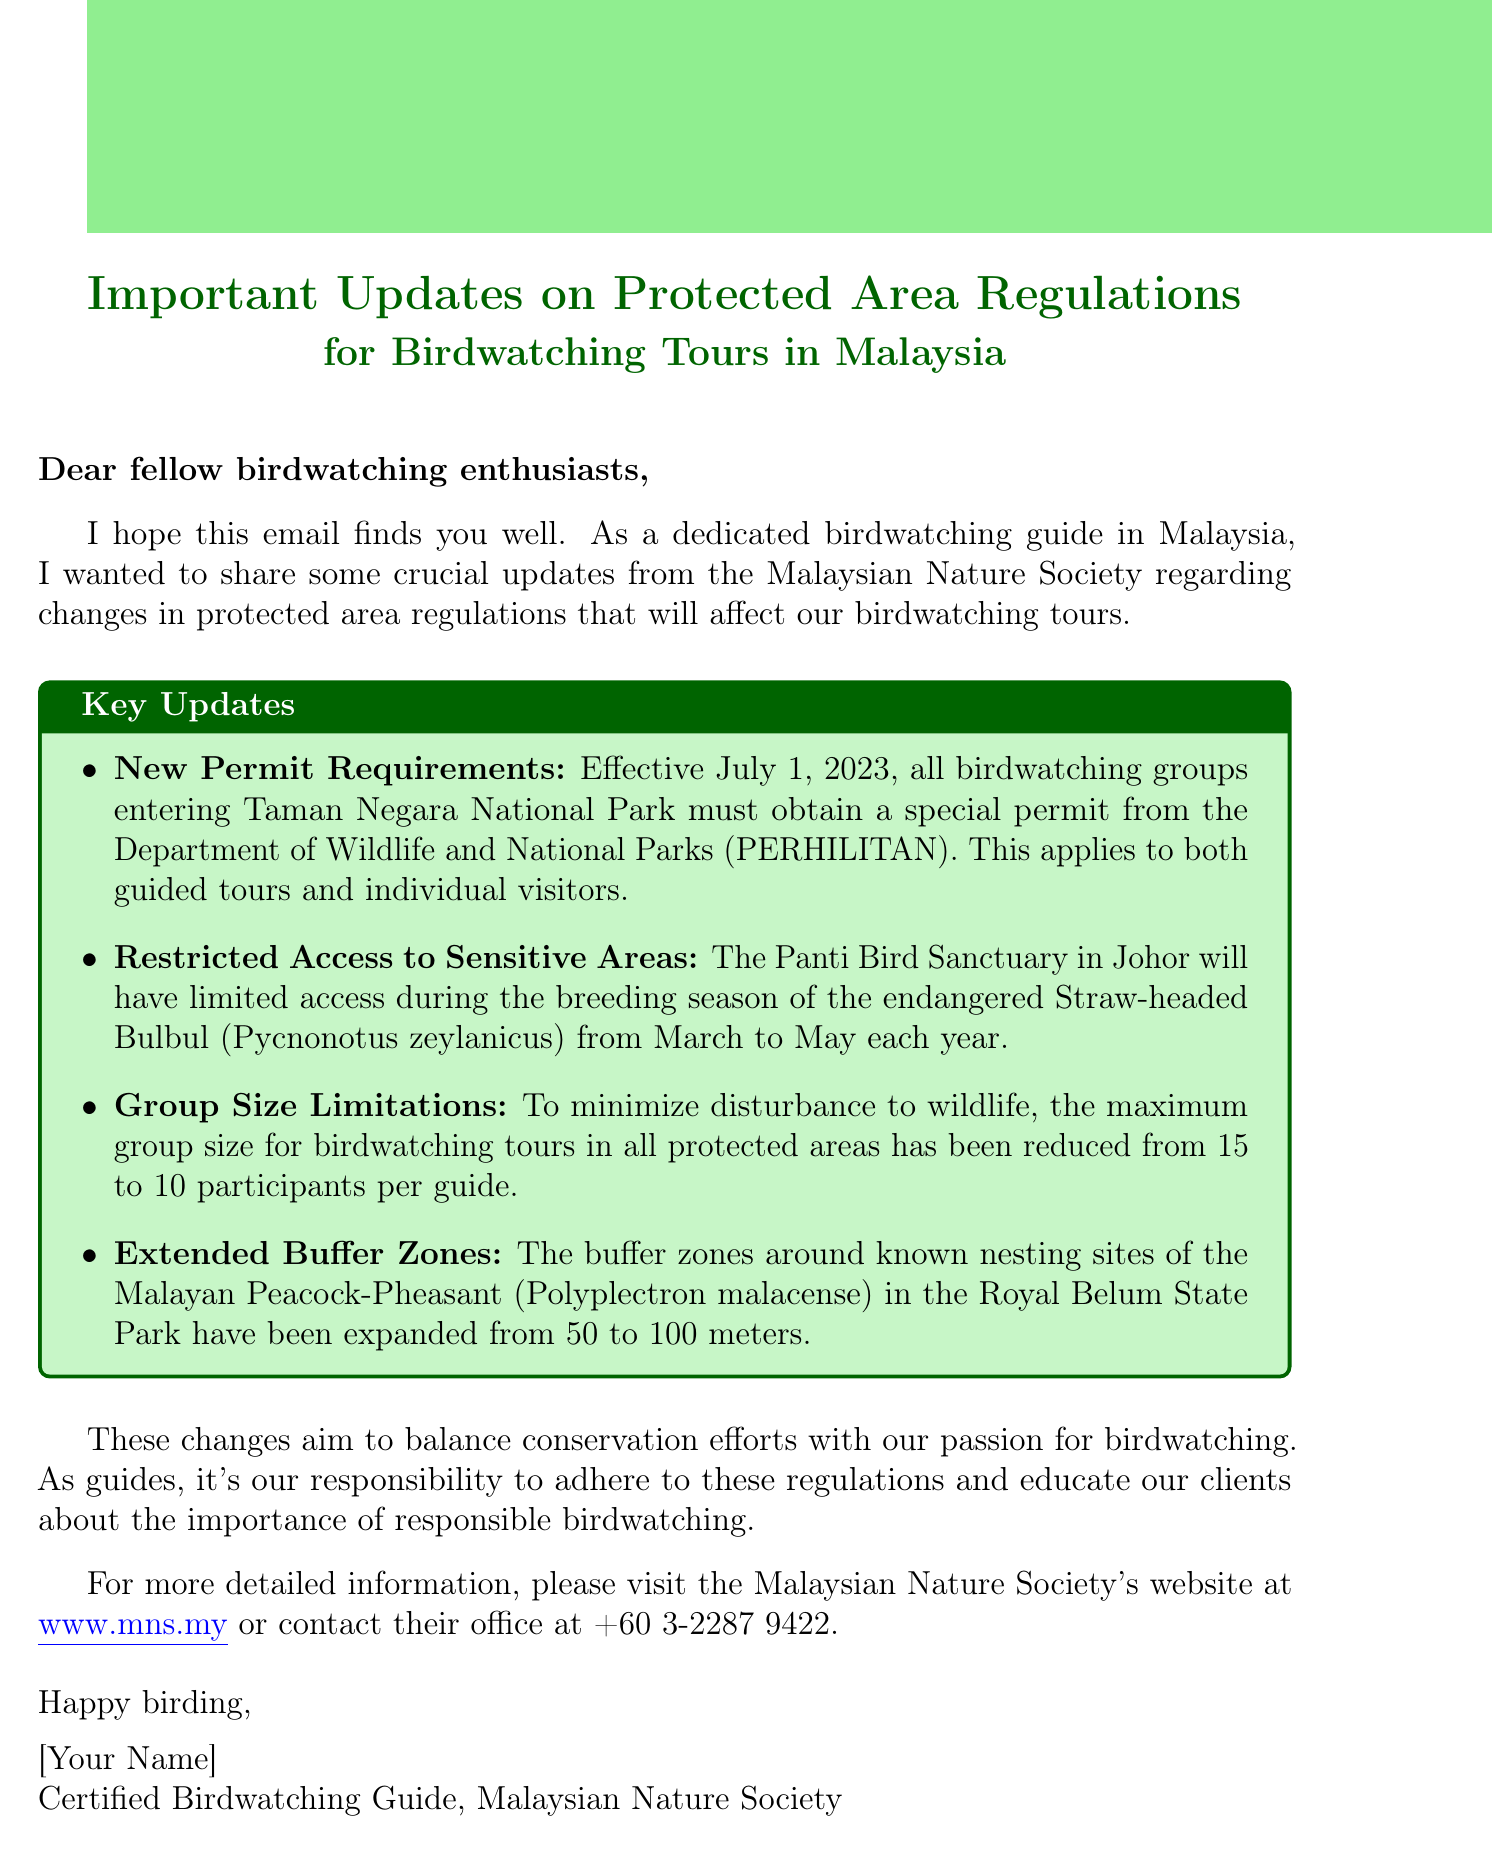What is the subject of the email? The subject of the email provides information about important updates related to protected area regulations for birdwatching tours in Malaysia.
Answer: Important Updates on Protected Area Regulations for Birdwatching Tours in Malaysia When did the new permit requirements take effect? The email states that the new permit requirements for birdwatching groups entering Taman Negara National Park are effective from a specific date.
Answer: July 1, 2023 What is the maximum group size for birdwatching tours now? The email mentions that the maximum group size for birdwatching tours in all protected areas has changed to minimize wildlife disturbance.
Answer: 10 participants Which bird species has restricted access during its breeding season? The email highlights the specific bird species that will have limited access in the Panti Bird Sanctuary during a designated time period.
Answer: Straw-headed Bulbul What is the newly expanded buffer zone around the Malayan Peacock-Pheasant's nesting sites? The email details the increase in buffer zones to protect the nesting sites of a specific bird species in the Royal Belum State Park.
Answer: 100 meters What is the purpose of these changes? The email summarizes the intention behind the updated regulations affecting birdwatching tours.
Answer: Balance conservation efforts How can one contact the Malaysian Nature Society for more information? The email provides a specific contact method for those wanting more details about the changes.
Answer: +60 3-2287 9422 What organization issued these updates? The email specifies the organization responsible for the updates regarding protected area regulations.
Answer: Malaysian Nature Society 